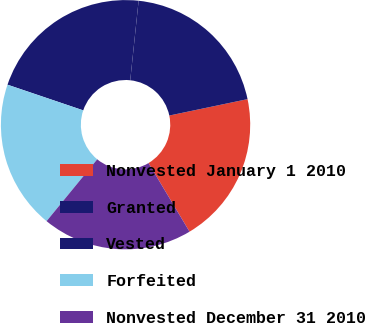Convert chart to OTSL. <chart><loc_0><loc_0><loc_500><loc_500><pie_chart><fcel>Nonvested January 1 2010<fcel>Granted<fcel>Vested<fcel>Forfeited<fcel>Nonvested December 31 2010<nl><fcel>19.71%<fcel>20.04%<fcel>21.47%<fcel>19.28%<fcel>19.5%<nl></chart> 